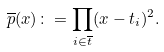Convert formula to latex. <formula><loc_0><loc_0><loc_500><loc_500>\overline { p } ( x ) \colon = \prod _ { i \in \overline { t } } ( x - t _ { i } ) ^ { 2 } .</formula> 